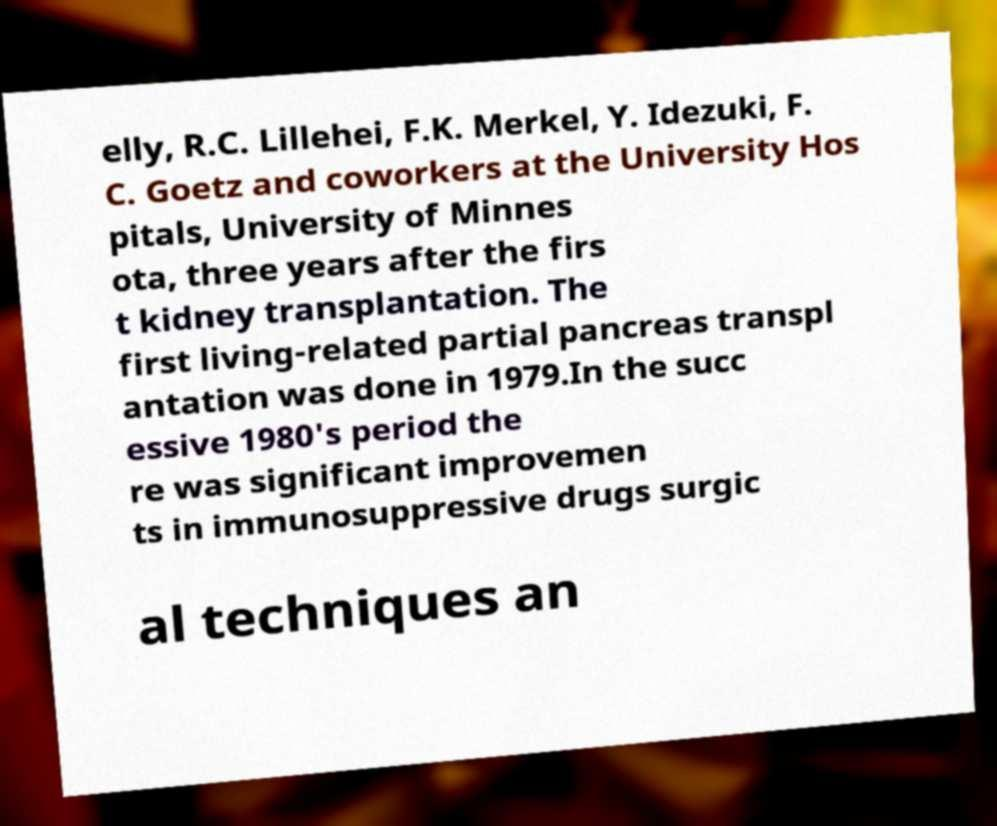There's text embedded in this image that I need extracted. Can you transcribe it verbatim? elly, R.C. Lillehei, F.K. Merkel, Y. Idezuki, F. C. Goetz and coworkers at the University Hos pitals, University of Minnes ota, three years after the firs t kidney transplantation. The first living-related partial pancreas transpl antation was done in 1979.In the succ essive 1980's period the re was significant improvemen ts in immunosuppressive drugs surgic al techniques an 